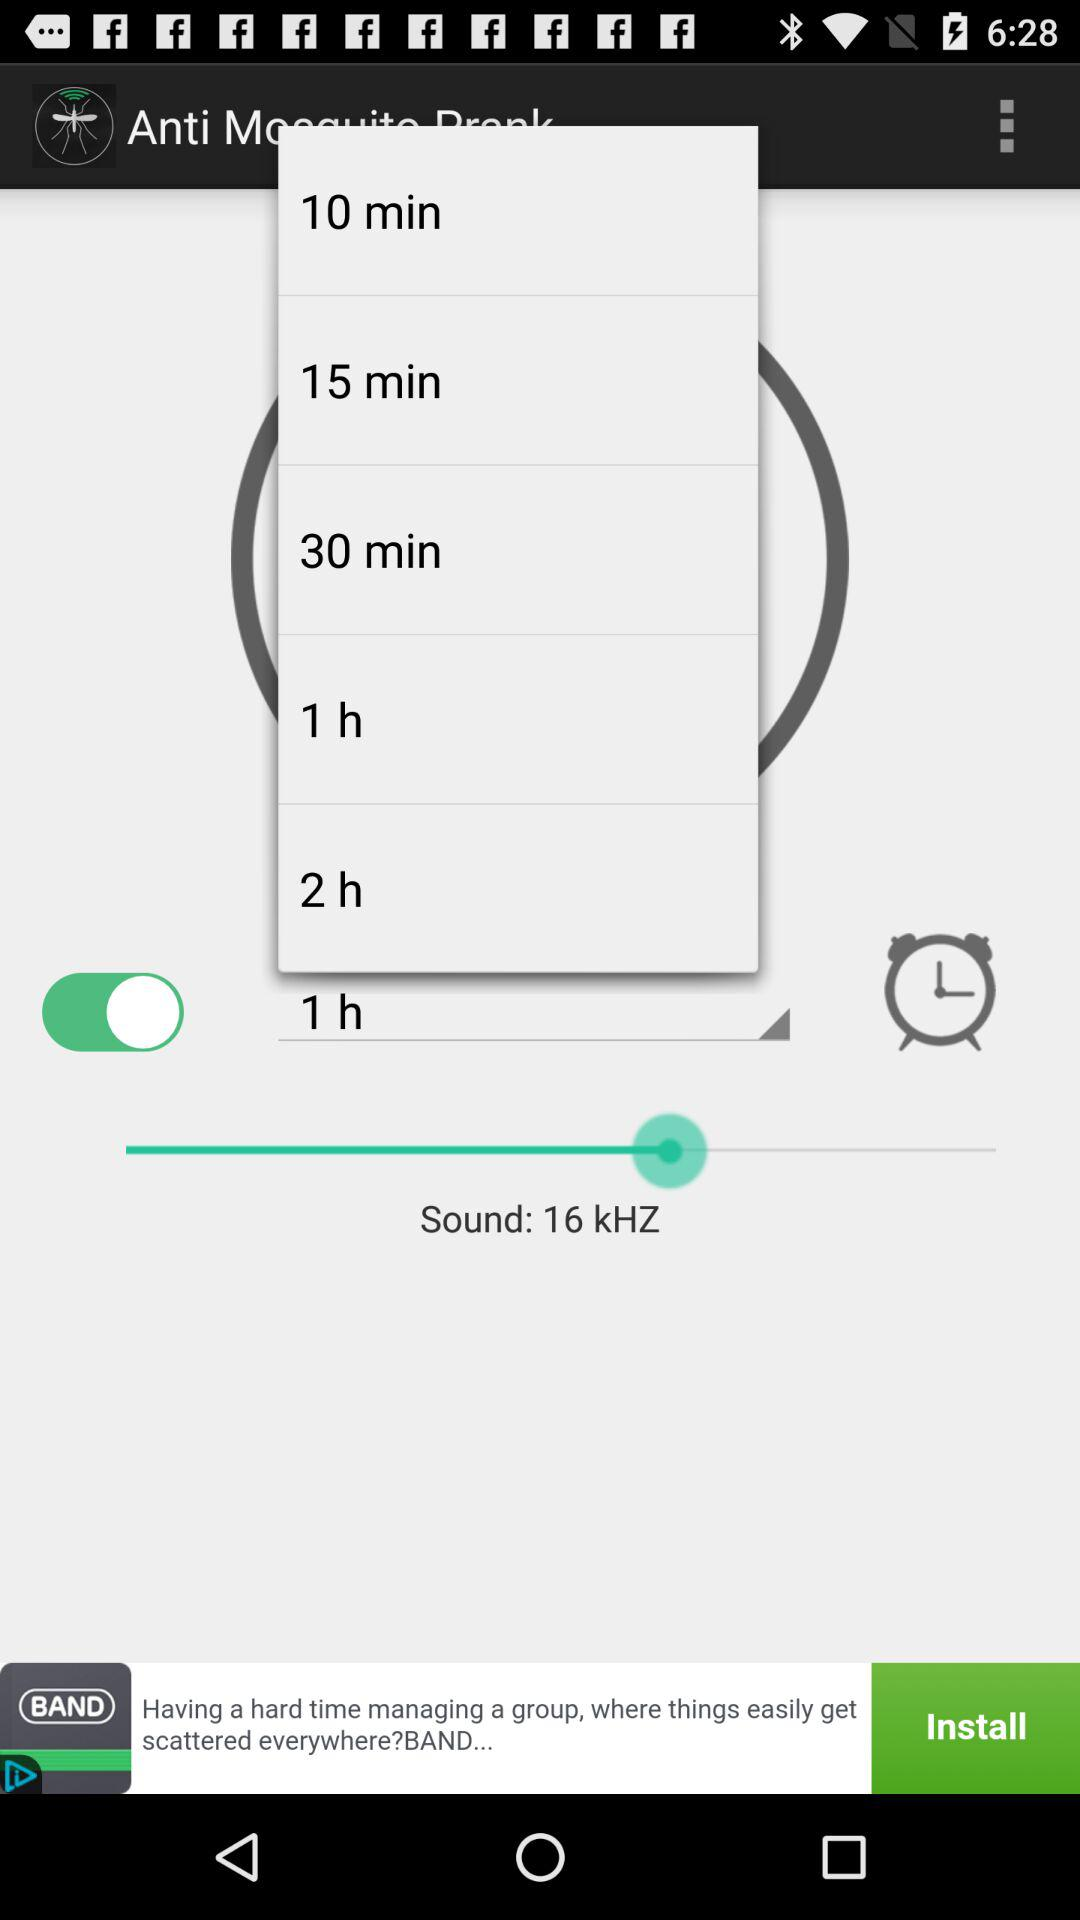What is the entered time duration? The entered time duration is 1 hour. 